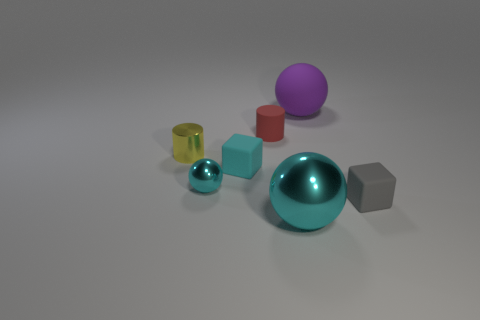Add 2 large objects. How many objects exist? 9 Subtract all balls. How many objects are left? 4 Subtract 1 gray cubes. How many objects are left? 6 Subtract all large blue rubber cylinders. Subtract all matte objects. How many objects are left? 3 Add 3 cyan balls. How many cyan balls are left? 5 Add 7 matte blocks. How many matte blocks exist? 9 